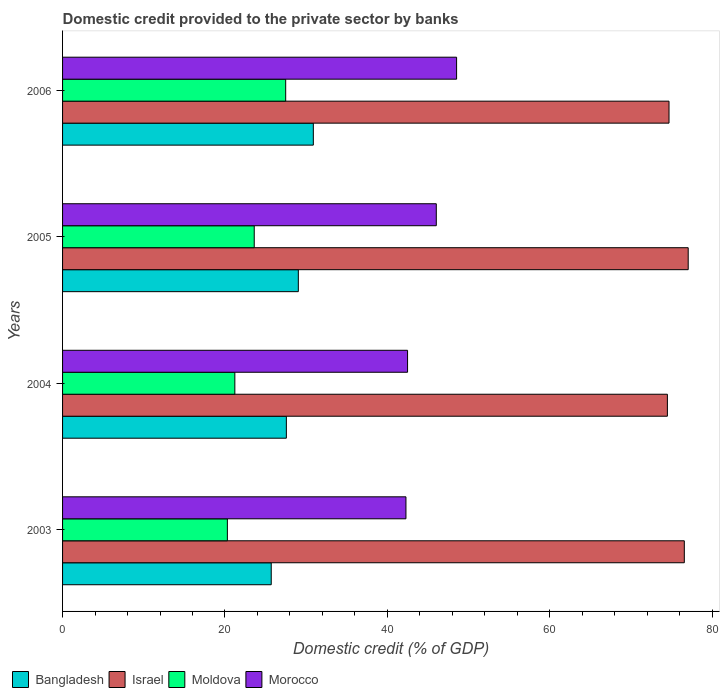How many different coloured bars are there?
Your response must be concise. 4. How many groups of bars are there?
Your answer should be compact. 4. Are the number of bars per tick equal to the number of legend labels?
Your answer should be very brief. Yes. Are the number of bars on each tick of the Y-axis equal?
Keep it short and to the point. Yes. How many bars are there on the 3rd tick from the bottom?
Offer a very short reply. 4. What is the label of the 4th group of bars from the top?
Your answer should be very brief. 2003. In how many cases, is the number of bars for a given year not equal to the number of legend labels?
Ensure brevity in your answer.  0. What is the domestic credit provided to the private sector by banks in Israel in 2006?
Provide a short and direct response. 74.67. Across all years, what is the maximum domestic credit provided to the private sector by banks in Israel?
Offer a very short reply. 77.04. Across all years, what is the minimum domestic credit provided to the private sector by banks in Moldova?
Offer a terse response. 20.29. In which year was the domestic credit provided to the private sector by banks in Morocco minimum?
Keep it short and to the point. 2003. What is the total domestic credit provided to the private sector by banks in Bangladesh in the graph?
Offer a very short reply. 113.16. What is the difference between the domestic credit provided to the private sector by banks in Moldova in 2003 and that in 2004?
Provide a short and direct response. -0.92. What is the difference between the domestic credit provided to the private sector by banks in Bangladesh in 2006 and the domestic credit provided to the private sector by banks in Moldova in 2005?
Your response must be concise. 7.28. What is the average domestic credit provided to the private sector by banks in Bangladesh per year?
Your response must be concise. 28.29. In the year 2003, what is the difference between the domestic credit provided to the private sector by banks in Moldova and domestic credit provided to the private sector by banks in Morocco?
Give a very brief answer. -21.99. In how many years, is the domestic credit provided to the private sector by banks in Morocco greater than 20 %?
Give a very brief answer. 4. What is the ratio of the domestic credit provided to the private sector by banks in Moldova in 2004 to that in 2005?
Provide a short and direct response. 0.9. What is the difference between the highest and the second highest domestic credit provided to the private sector by banks in Moldova?
Provide a short and direct response. 3.87. What is the difference between the highest and the lowest domestic credit provided to the private sector by banks in Moldova?
Your response must be concise. 7.18. In how many years, is the domestic credit provided to the private sector by banks in Bangladesh greater than the average domestic credit provided to the private sector by banks in Bangladesh taken over all years?
Offer a very short reply. 2. What does the 1st bar from the top in 2006 represents?
Offer a terse response. Morocco. What does the 1st bar from the bottom in 2004 represents?
Keep it short and to the point. Bangladesh. Are all the bars in the graph horizontal?
Ensure brevity in your answer.  Yes. How many years are there in the graph?
Offer a very short reply. 4. What is the difference between two consecutive major ticks on the X-axis?
Provide a succinct answer. 20. Are the values on the major ticks of X-axis written in scientific E-notation?
Offer a terse response. No. Does the graph contain any zero values?
Give a very brief answer. No. Does the graph contain grids?
Your answer should be very brief. No. How are the legend labels stacked?
Your response must be concise. Horizontal. What is the title of the graph?
Offer a terse response. Domestic credit provided to the private sector by banks. What is the label or title of the X-axis?
Offer a very short reply. Domestic credit (% of GDP). What is the label or title of the Y-axis?
Ensure brevity in your answer.  Years. What is the Domestic credit (% of GDP) of Bangladesh in 2003?
Keep it short and to the point. 25.69. What is the Domestic credit (% of GDP) of Israel in 2003?
Offer a terse response. 76.56. What is the Domestic credit (% of GDP) of Moldova in 2003?
Your answer should be very brief. 20.29. What is the Domestic credit (% of GDP) of Morocco in 2003?
Your response must be concise. 42.28. What is the Domestic credit (% of GDP) of Bangladesh in 2004?
Provide a succinct answer. 27.56. What is the Domestic credit (% of GDP) in Israel in 2004?
Your answer should be very brief. 74.47. What is the Domestic credit (% of GDP) of Moldova in 2004?
Your response must be concise. 21.21. What is the Domestic credit (% of GDP) of Morocco in 2004?
Your response must be concise. 42.48. What is the Domestic credit (% of GDP) of Bangladesh in 2005?
Offer a terse response. 29.03. What is the Domestic credit (% of GDP) of Israel in 2005?
Give a very brief answer. 77.04. What is the Domestic credit (% of GDP) in Moldova in 2005?
Offer a very short reply. 23.6. What is the Domestic credit (% of GDP) in Morocco in 2005?
Make the answer very short. 46.02. What is the Domestic credit (% of GDP) in Bangladesh in 2006?
Offer a very short reply. 30.88. What is the Domestic credit (% of GDP) in Israel in 2006?
Offer a very short reply. 74.67. What is the Domestic credit (% of GDP) of Moldova in 2006?
Provide a short and direct response. 27.47. What is the Domestic credit (% of GDP) of Morocco in 2006?
Make the answer very short. 48.52. Across all years, what is the maximum Domestic credit (% of GDP) in Bangladesh?
Offer a terse response. 30.88. Across all years, what is the maximum Domestic credit (% of GDP) of Israel?
Your answer should be very brief. 77.04. Across all years, what is the maximum Domestic credit (% of GDP) of Moldova?
Ensure brevity in your answer.  27.47. Across all years, what is the maximum Domestic credit (% of GDP) of Morocco?
Offer a terse response. 48.52. Across all years, what is the minimum Domestic credit (% of GDP) of Bangladesh?
Make the answer very short. 25.69. Across all years, what is the minimum Domestic credit (% of GDP) in Israel?
Your response must be concise. 74.47. Across all years, what is the minimum Domestic credit (% of GDP) of Moldova?
Provide a succinct answer. 20.29. Across all years, what is the minimum Domestic credit (% of GDP) in Morocco?
Provide a succinct answer. 42.28. What is the total Domestic credit (% of GDP) of Bangladesh in the graph?
Ensure brevity in your answer.  113.16. What is the total Domestic credit (% of GDP) of Israel in the graph?
Your answer should be very brief. 302.75. What is the total Domestic credit (% of GDP) of Moldova in the graph?
Give a very brief answer. 92.58. What is the total Domestic credit (% of GDP) in Morocco in the graph?
Ensure brevity in your answer.  179.3. What is the difference between the Domestic credit (% of GDP) in Bangladesh in 2003 and that in 2004?
Keep it short and to the point. -1.86. What is the difference between the Domestic credit (% of GDP) in Israel in 2003 and that in 2004?
Give a very brief answer. 2.08. What is the difference between the Domestic credit (% of GDP) of Moldova in 2003 and that in 2004?
Give a very brief answer. -0.92. What is the difference between the Domestic credit (% of GDP) in Morocco in 2003 and that in 2004?
Keep it short and to the point. -0.2. What is the difference between the Domestic credit (% of GDP) of Bangladesh in 2003 and that in 2005?
Provide a succinct answer. -3.34. What is the difference between the Domestic credit (% of GDP) in Israel in 2003 and that in 2005?
Your answer should be compact. -0.48. What is the difference between the Domestic credit (% of GDP) of Moldova in 2003 and that in 2005?
Offer a very short reply. -3.31. What is the difference between the Domestic credit (% of GDP) of Morocco in 2003 and that in 2005?
Your answer should be very brief. -3.74. What is the difference between the Domestic credit (% of GDP) of Bangladesh in 2003 and that in 2006?
Keep it short and to the point. -5.18. What is the difference between the Domestic credit (% of GDP) of Israel in 2003 and that in 2006?
Make the answer very short. 1.88. What is the difference between the Domestic credit (% of GDP) in Moldova in 2003 and that in 2006?
Ensure brevity in your answer.  -7.18. What is the difference between the Domestic credit (% of GDP) in Morocco in 2003 and that in 2006?
Give a very brief answer. -6.24. What is the difference between the Domestic credit (% of GDP) in Bangladesh in 2004 and that in 2005?
Your response must be concise. -1.47. What is the difference between the Domestic credit (% of GDP) in Israel in 2004 and that in 2005?
Your answer should be very brief. -2.56. What is the difference between the Domestic credit (% of GDP) in Moldova in 2004 and that in 2005?
Ensure brevity in your answer.  -2.39. What is the difference between the Domestic credit (% of GDP) of Morocco in 2004 and that in 2005?
Offer a terse response. -3.54. What is the difference between the Domestic credit (% of GDP) of Bangladesh in 2004 and that in 2006?
Keep it short and to the point. -3.32. What is the difference between the Domestic credit (% of GDP) of Israel in 2004 and that in 2006?
Your answer should be very brief. -0.2. What is the difference between the Domestic credit (% of GDP) of Moldova in 2004 and that in 2006?
Ensure brevity in your answer.  -6.26. What is the difference between the Domestic credit (% of GDP) of Morocco in 2004 and that in 2006?
Provide a short and direct response. -6.04. What is the difference between the Domestic credit (% of GDP) in Bangladesh in 2005 and that in 2006?
Provide a succinct answer. -1.85. What is the difference between the Domestic credit (% of GDP) in Israel in 2005 and that in 2006?
Keep it short and to the point. 2.36. What is the difference between the Domestic credit (% of GDP) in Moldova in 2005 and that in 2006?
Offer a terse response. -3.87. What is the difference between the Domestic credit (% of GDP) in Morocco in 2005 and that in 2006?
Keep it short and to the point. -2.5. What is the difference between the Domestic credit (% of GDP) of Bangladesh in 2003 and the Domestic credit (% of GDP) of Israel in 2004?
Give a very brief answer. -48.78. What is the difference between the Domestic credit (% of GDP) of Bangladesh in 2003 and the Domestic credit (% of GDP) of Moldova in 2004?
Keep it short and to the point. 4.48. What is the difference between the Domestic credit (% of GDP) of Bangladesh in 2003 and the Domestic credit (% of GDP) of Morocco in 2004?
Keep it short and to the point. -16.79. What is the difference between the Domestic credit (% of GDP) of Israel in 2003 and the Domestic credit (% of GDP) of Moldova in 2004?
Your response must be concise. 55.35. What is the difference between the Domestic credit (% of GDP) in Israel in 2003 and the Domestic credit (% of GDP) in Morocco in 2004?
Offer a terse response. 34.08. What is the difference between the Domestic credit (% of GDP) in Moldova in 2003 and the Domestic credit (% of GDP) in Morocco in 2004?
Offer a very short reply. -22.19. What is the difference between the Domestic credit (% of GDP) of Bangladesh in 2003 and the Domestic credit (% of GDP) of Israel in 2005?
Ensure brevity in your answer.  -51.34. What is the difference between the Domestic credit (% of GDP) in Bangladesh in 2003 and the Domestic credit (% of GDP) in Moldova in 2005?
Offer a terse response. 2.09. What is the difference between the Domestic credit (% of GDP) of Bangladesh in 2003 and the Domestic credit (% of GDP) of Morocco in 2005?
Ensure brevity in your answer.  -20.33. What is the difference between the Domestic credit (% of GDP) of Israel in 2003 and the Domestic credit (% of GDP) of Moldova in 2005?
Ensure brevity in your answer.  52.96. What is the difference between the Domestic credit (% of GDP) in Israel in 2003 and the Domestic credit (% of GDP) in Morocco in 2005?
Your answer should be compact. 30.54. What is the difference between the Domestic credit (% of GDP) of Moldova in 2003 and the Domestic credit (% of GDP) of Morocco in 2005?
Keep it short and to the point. -25.73. What is the difference between the Domestic credit (% of GDP) of Bangladesh in 2003 and the Domestic credit (% of GDP) of Israel in 2006?
Offer a terse response. -48.98. What is the difference between the Domestic credit (% of GDP) in Bangladesh in 2003 and the Domestic credit (% of GDP) in Moldova in 2006?
Offer a very short reply. -1.78. What is the difference between the Domestic credit (% of GDP) of Bangladesh in 2003 and the Domestic credit (% of GDP) of Morocco in 2006?
Give a very brief answer. -22.82. What is the difference between the Domestic credit (% of GDP) of Israel in 2003 and the Domestic credit (% of GDP) of Moldova in 2006?
Your answer should be compact. 49.09. What is the difference between the Domestic credit (% of GDP) in Israel in 2003 and the Domestic credit (% of GDP) in Morocco in 2006?
Your answer should be very brief. 28.04. What is the difference between the Domestic credit (% of GDP) of Moldova in 2003 and the Domestic credit (% of GDP) of Morocco in 2006?
Offer a very short reply. -28.22. What is the difference between the Domestic credit (% of GDP) in Bangladesh in 2004 and the Domestic credit (% of GDP) in Israel in 2005?
Offer a very short reply. -49.48. What is the difference between the Domestic credit (% of GDP) in Bangladesh in 2004 and the Domestic credit (% of GDP) in Moldova in 2005?
Make the answer very short. 3.95. What is the difference between the Domestic credit (% of GDP) of Bangladesh in 2004 and the Domestic credit (% of GDP) of Morocco in 2005?
Your answer should be compact. -18.46. What is the difference between the Domestic credit (% of GDP) in Israel in 2004 and the Domestic credit (% of GDP) in Moldova in 2005?
Ensure brevity in your answer.  50.87. What is the difference between the Domestic credit (% of GDP) in Israel in 2004 and the Domestic credit (% of GDP) in Morocco in 2005?
Offer a very short reply. 28.45. What is the difference between the Domestic credit (% of GDP) of Moldova in 2004 and the Domestic credit (% of GDP) of Morocco in 2005?
Provide a succinct answer. -24.81. What is the difference between the Domestic credit (% of GDP) of Bangladesh in 2004 and the Domestic credit (% of GDP) of Israel in 2006?
Offer a very short reply. -47.12. What is the difference between the Domestic credit (% of GDP) in Bangladesh in 2004 and the Domestic credit (% of GDP) in Moldova in 2006?
Ensure brevity in your answer.  0.08. What is the difference between the Domestic credit (% of GDP) in Bangladesh in 2004 and the Domestic credit (% of GDP) in Morocco in 2006?
Provide a succinct answer. -20.96. What is the difference between the Domestic credit (% of GDP) of Israel in 2004 and the Domestic credit (% of GDP) of Moldova in 2006?
Keep it short and to the point. 47. What is the difference between the Domestic credit (% of GDP) of Israel in 2004 and the Domestic credit (% of GDP) of Morocco in 2006?
Your response must be concise. 25.96. What is the difference between the Domestic credit (% of GDP) in Moldova in 2004 and the Domestic credit (% of GDP) in Morocco in 2006?
Provide a succinct answer. -27.31. What is the difference between the Domestic credit (% of GDP) in Bangladesh in 2005 and the Domestic credit (% of GDP) in Israel in 2006?
Provide a short and direct response. -45.64. What is the difference between the Domestic credit (% of GDP) in Bangladesh in 2005 and the Domestic credit (% of GDP) in Moldova in 2006?
Provide a short and direct response. 1.56. What is the difference between the Domestic credit (% of GDP) of Bangladesh in 2005 and the Domestic credit (% of GDP) of Morocco in 2006?
Make the answer very short. -19.49. What is the difference between the Domestic credit (% of GDP) in Israel in 2005 and the Domestic credit (% of GDP) in Moldova in 2006?
Offer a very short reply. 49.56. What is the difference between the Domestic credit (% of GDP) of Israel in 2005 and the Domestic credit (% of GDP) of Morocco in 2006?
Ensure brevity in your answer.  28.52. What is the difference between the Domestic credit (% of GDP) of Moldova in 2005 and the Domestic credit (% of GDP) of Morocco in 2006?
Give a very brief answer. -24.92. What is the average Domestic credit (% of GDP) of Bangladesh per year?
Your answer should be compact. 28.29. What is the average Domestic credit (% of GDP) in Israel per year?
Your response must be concise. 75.69. What is the average Domestic credit (% of GDP) of Moldova per year?
Make the answer very short. 23.15. What is the average Domestic credit (% of GDP) in Morocco per year?
Provide a short and direct response. 44.83. In the year 2003, what is the difference between the Domestic credit (% of GDP) in Bangladesh and Domestic credit (% of GDP) in Israel?
Provide a succinct answer. -50.86. In the year 2003, what is the difference between the Domestic credit (% of GDP) of Bangladesh and Domestic credit (% of GDP) of Moldova?
Offer a terse response. 5.4. In the year 2003, what is the difference between the Domestic credit (% of GDP) in Bangladesh and Domestic credit (% of GDP) in Morocco?
Give a very brief answer. -16.59. In the year 2003, what is the difference between the Domestic credit (% of GDP) of Israel and Domestic credit (% of GDP) of Moldova?
Your answer should be very brief. 56.26. In the year 2003, what is the difference between the Domestic credit (% of GDP) of Israel and Domestic credit (% of GDP) of Morocco?
Keep it short and to the point. 34.28. In the year 2003, what is the difference between the Domestic credit (% of GDP) in Moldova and Domestic credit (% of GDP) in Morocco?
Make the answer very short. -21.99. In the year 2004, what is the difference between the Domestic credit (% of GDP) in Bangladesh and Domestic credit (% of GDP) in Israel?
Provide a succinct answer. -46.92. In the year 2004, what is the difference between the Domestic credit (% of GDP) in Bangladesh and Domestic credit (% of GDP) in Moldova?
Your response must be concise. 6.34. In the year 2004, what is the difference between the Domestic credit (% of GDP) in Bangladesh and Domestic credit (% of GDP) in Morocco?
Give a very brief answer. -14.92. In the year 2004, what is the difference between the Domestic credit (% of GDP) of Israel and Domestic credit (% of GDP) of Moldova?
Offer a terse response. 53.26. In the year 2004, what is the difference between the Domestic credit (% of GDP) in Israel and Domestic credit (% of GDP) in Morocco?
Provide a short and direct response. 31.99. In the year 2004, what is the difference between the Domestic credit (% of GDP) of Moldova and Domestic credit (% of GDP) of Morocco?
Give a very brief answer. -21.27. In the year 2005, what is the difference between the Domestic credit (% of GDP) of Bangladesh and Domestic credit (% of GDP) of Israel?
Offer a very short reply. -48.01. In the year 2005, what is the difference between the Domestic credit (% of GDP) of Bangladesh and Domestic credit (% of GDP) of Moldova?
Your answer should be compact. 5.43. In the year 2005, what is the difference between the Domestic credit (% of GDP) in Bangladesh and Domestic credit (% of GDP) in Morocco?
Offer a terse response. -16.99. In the year 2005, what is the difference between the Domestic credit (% of GDP) in Israel and Domestic credit (% of GDP) in Moldova?
Your response must be concise. 53.44. In the year 2005, what is the difference between the Domestic credit (% of GDP) of Israel and Domestic credit (% of GDP) of Morocco?
Your answer should be very brief. 31.02. In the year 2005, what is the difference between the Domestic credit (% of GDP) of Moldova and Domestic credit (% of GDP) of Morocco?
Provide a short and direct response. -22.42. In the year 2006, what is the difference between the Domestic credit (% of GDP) of Bangladesh and Domestic credit (% of GDP) of Israel?
Ensure brevity in your answer.  -43.8. In the year 2006, what is the difference between the Domestic credit (% of GDP) in Bangladesh and Domestic credit (% of GDP) in Moldova?
Ensure brevity in your answer.  3.4. In the year 2006, what is the difference between the Domestic credit (% of GDP) of Bangladesh and Domestic credit (% of GDP) of Morocco?
Make the answer very short. -17.64. In the year 2006, what is the difference between the Domestic credit (% of GDP) in Israel and Domestic credit (% of GDP) in Moldova?
Your answer should be compact. 47.2. In the year 2006, what is the difference between the Domestic credit (% of GDP) of Israel and Domestic credit (% of GDP) of Morocco?
Offer a terse response. 26.16. In the year 2006, what is the difference between the Domestic credit (% of GDP) of Moldova and Domestic credit (% of GDP) of Morocco?
Keep it short and to the point. -21.05. What is the ratio of the Domestic credit (% of GDP) of Bangladesh in 2003 to that in 2004?
Your answer should be very brief. 0.93. What is the ratio of the Domestic credit (% of GDP) in Israel in 2003 to that in 2004?
Offer a very short reply. 1.03. What is the ratio of the Domestic credit (% of GDP) of Moldova in 2003 to that in 2004?
Provide a short and direct response. 0.96. What is the ratio of the Domestic credit (% of GDP) in Morocco in 2003 to that in 2004?
Ensure brevity in your answer.  1. What is the ratio of the Domestic credit (% of GDP) of Bangladesh in 2003 to that in 2005?
Make the answer very short. 0.89. What is the ratio of the Domestic credit (% of GDP) in Moldova in 2003 to that in 2005?
Offer a terse response. 0.86. What is the ratio of the Domestic credit (% of GDP) of Morocco in 2003 to that in 2005?
Give a very brief answer. 0.92. What is the ratio of the Domestic credit (% of GDP) of Bangladesh in 2003 to that in 2006?
Offer a terse response. 0.83. What is the ratio of the Domestic credit (% of GDP) of Israel in 2003 to that in 2006?
Provide a succinct answer. 1.03. What is the ratio of the Domestic credit (% of GDP) of Moldova in 2003 to that in 2006?
Provide a succinct answer. 0.74. What is the ratio of the Domestic credit (% of GDP) of Morocco in 2003 to that in 2006?
Your response must be concise. 0.87. What is the ratio of the Domestic credit (% of GDP) of Bangladesh in 2004 to that in 2005?
Keep it short and to the point. 0.95. What is the ratio of the Domestic credit (% of GDP) in Israel in 2004 to that in 2005?
Offer a terse response. 0.97. What is the ratio of the Domestic credit (% of GDP) in Moldova in 2004 to that in 2005?
Your answer should be compact. 0.9. What is the ratio of the Domestic credit (% of GDP) in Morocco in 2004 to that in 2005?
Make the answer very short. 0.92. What is the ratio of the Domestic credit (% of GDP) of Bangladesh in 2004 to that in 2006?
Offer a terse response. 0.89. What is the ratio of the Domestic credit (% of GDP) in Israel in 2004 to that in 2006?
Keep it short and to the point. 1. What is the ratio of the Domestic credit (% of GDP) of Moldova in 2004 to that in 2006?
Keep it short and to the point. 0.77. What is the ratio of the Domestic credit (% of GDP) of Morocco in 2004 to that in 2006?
Your answer should be compact. 0.88. What is the ratio of the Domestic credit (% of GDP) of Bangladesh in 2005 to that in 2006?
Offer a very short reply. 0.94. What is the ratio of the Domestic credit (% of GDP) of Israel in 2005 to that in 2006?
Give a very brief answer. 1.03. What is the ratio of the Domestic credit (% of GDP) of Moldova in 2005 to that in 2006?
Your answer should be very brief. 0.86. What is the ratio of the Domestic credit (% of GDP) of Morocco in 2005 to that in 2006?
Give a very brief answer. 0.95. What is the difference between the highest and the second highest Domestic credit (% of GDP) in Bangladesh?
Give a very brief answer. 1.85. What is the difference between the highest and the second highest Domestic credit (% of GDP) of Israel?
Your answer should be compact. 0.48. What is the difference between the highest and the second highest Domestic credit (% of GDP) in Moldova?
Provide a short and direct response. 3.87. What is the difference between the highest and the second highest Domestic credit (% of GDP) in Morocco?
Provide a short and direct response. 2.5. What is the difference between the highest and the lowest Domestic credit (% of GDP) in Bangladesh?
Your answer should be very brief. 5.18. What is the difference between the highest and the lowest Domestic credit (% of GDP) in Israel?
Your answer should be very brief. 2.56. What is the difference between the highest and the lowest Domestic credit (% of GDP) of Moldova?
Keep it short and to the point. 7.18. What is the difference between the highest and the lowest Domestic credit (% of GDP) in Morocco?
Keep it short and to the point. 6.24. 